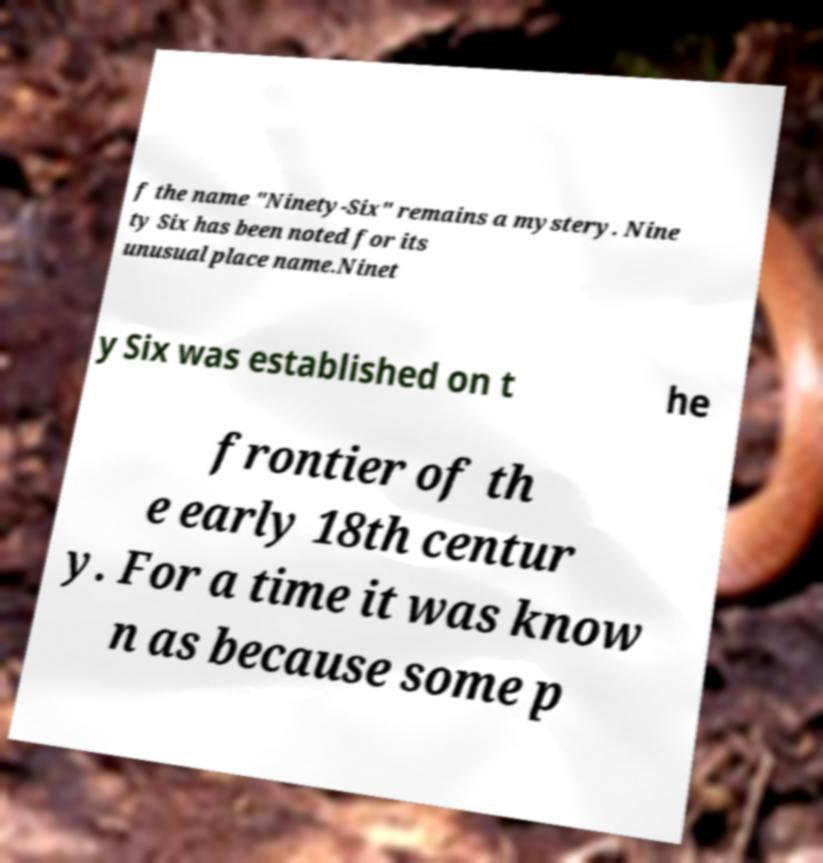Can you read and provide the text displayed in the image?This photo seems to have some interesting text. Can you extract and type it out for me? f the name "Ninety-Six" remains a mystery. Nine ty Six has been noted for its unusual place name.Ninet y Six was established on t he frontier of th e early 18th centur y. For a time it was know n as because some p 